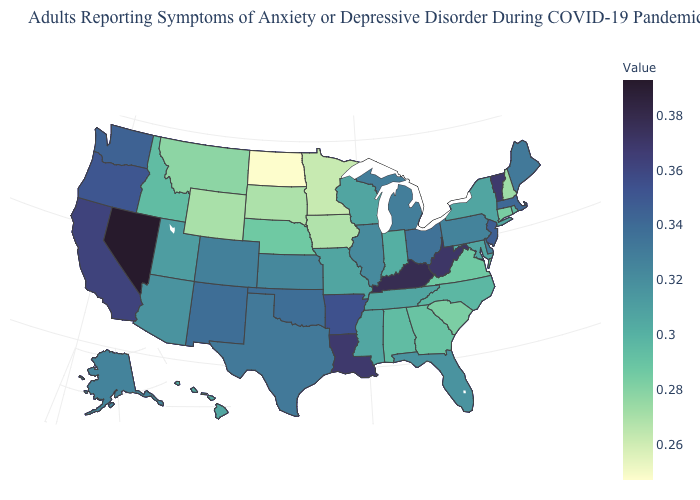Does South Carolina have a lower value than Illinois?
Keep it brief. Yes. 